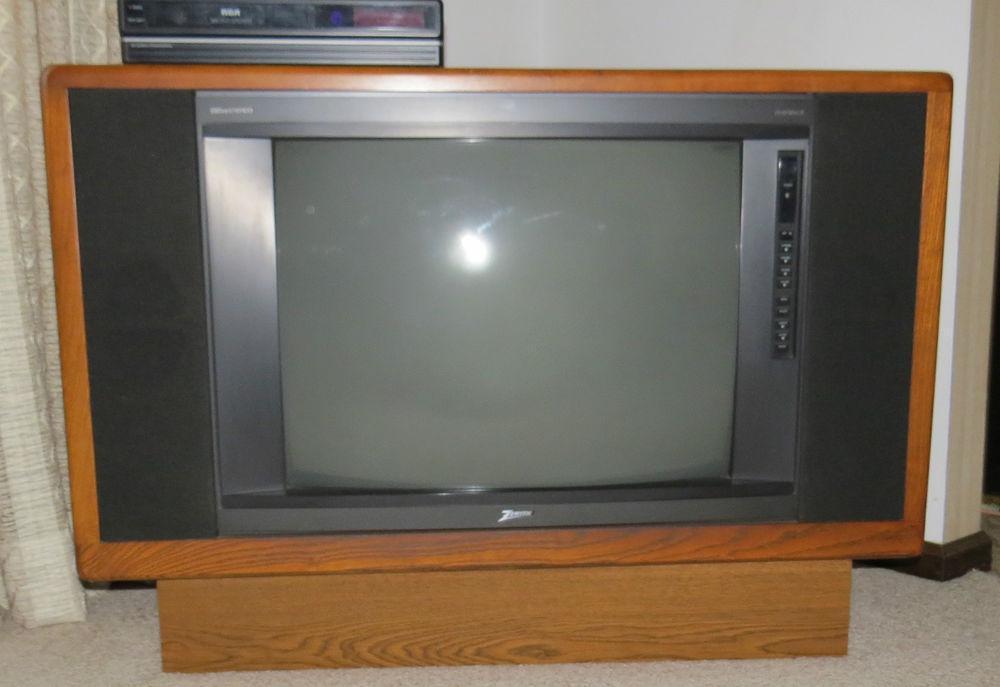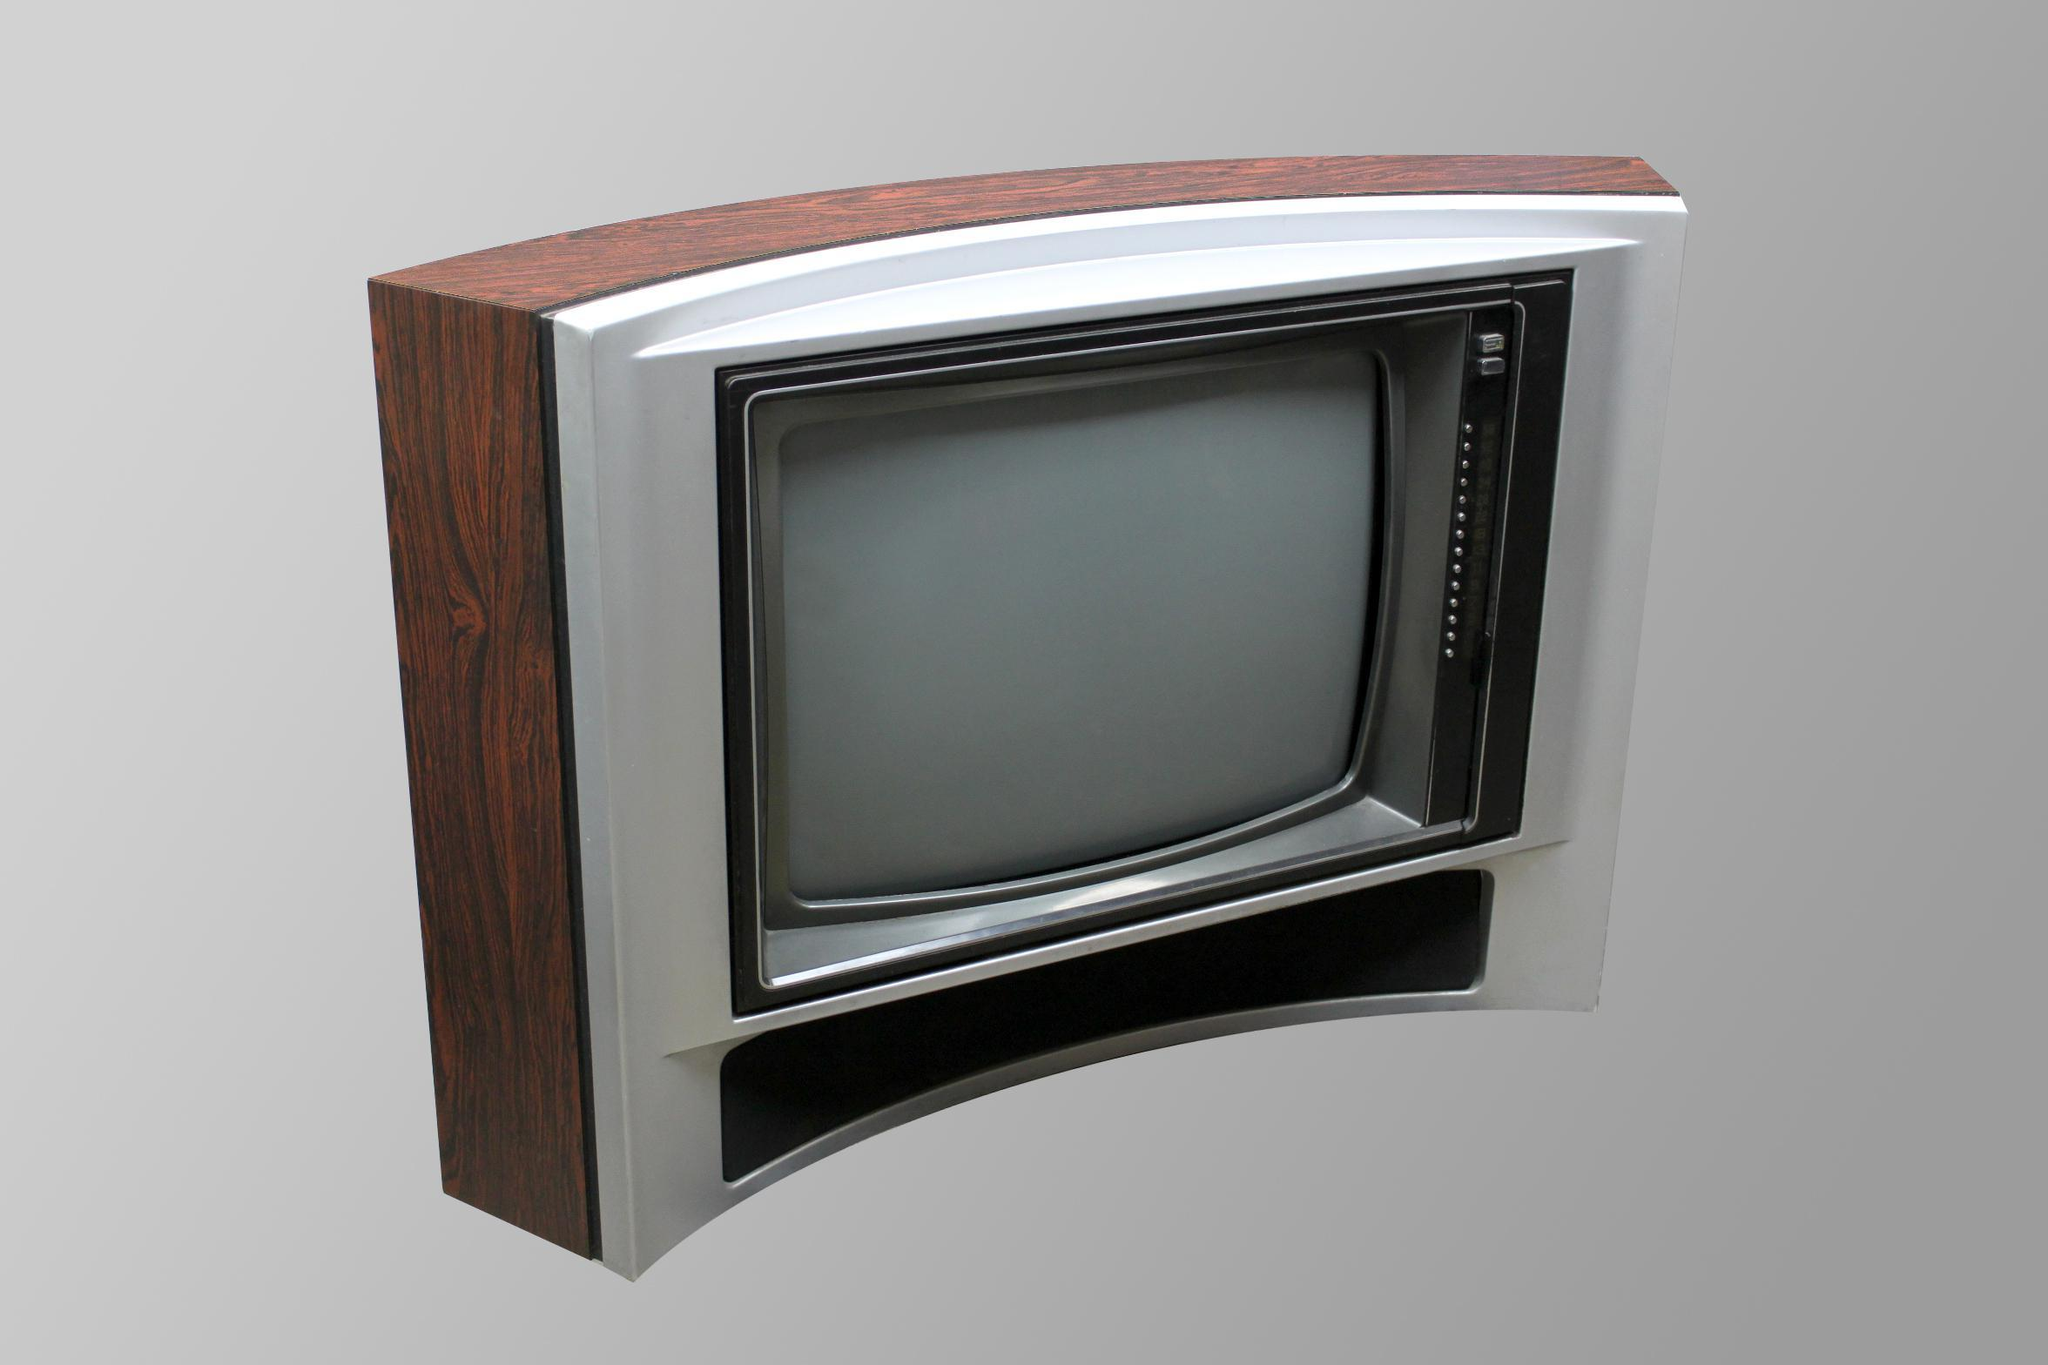The first image is the image on the left, the second image is the image on the right. Examine the images to the left and right. Is the description "At least one object sit atop the television in the image on the left." accurate? Answer yes or no. Yes. 